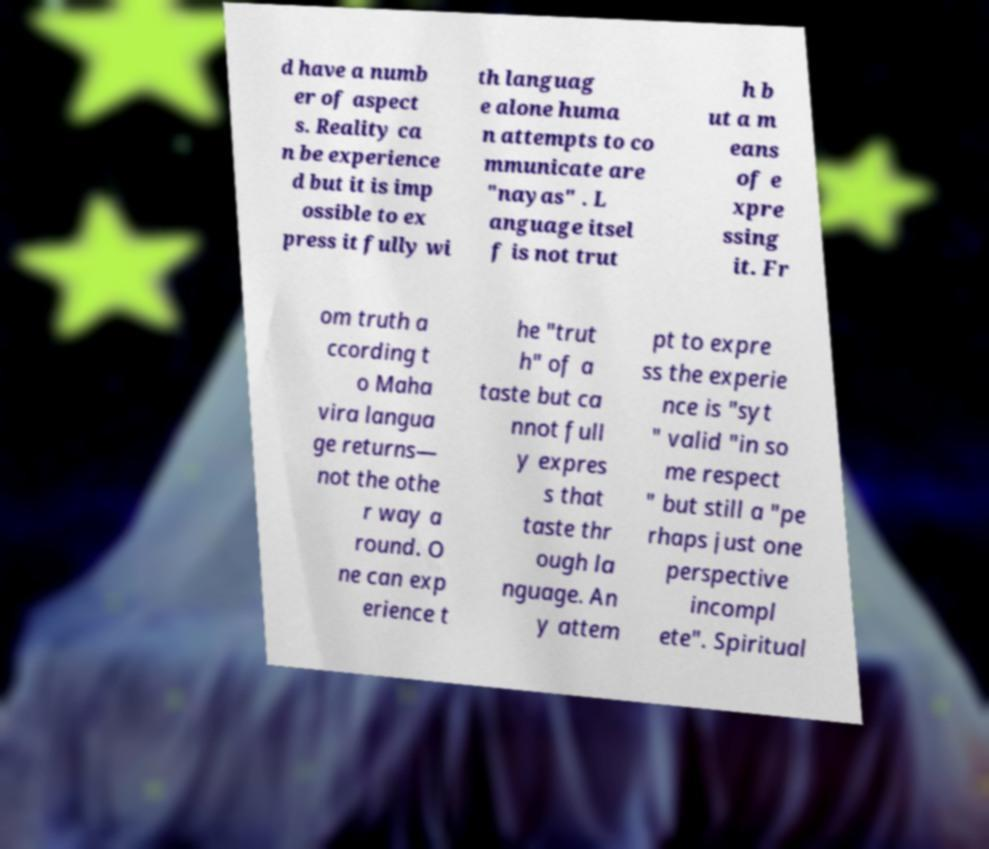Could you assist in decoding the text presented in this image and type it out clearly? d have a numb er of aspect s. Reality ca n be experience d but it is imp ossible to ex press it fully wi th languag e alone huma n attempts to co mmunicate are "nayas" . L anguage itsel f is not trut h b ut a m eans of e xpre ssing it. Fr om truth a ccording t o Maha vira langua ge returns— not the othe r way a round. O ne can exp erience t he "trut h" of a taste but ca nnot full y expres s that taste thr ough la nguage. An y attem pt to expre ss the experie nce is "syt " valid "in so me respect " but still a "pe rhaps just one perspective incompl ete". Spiritual 